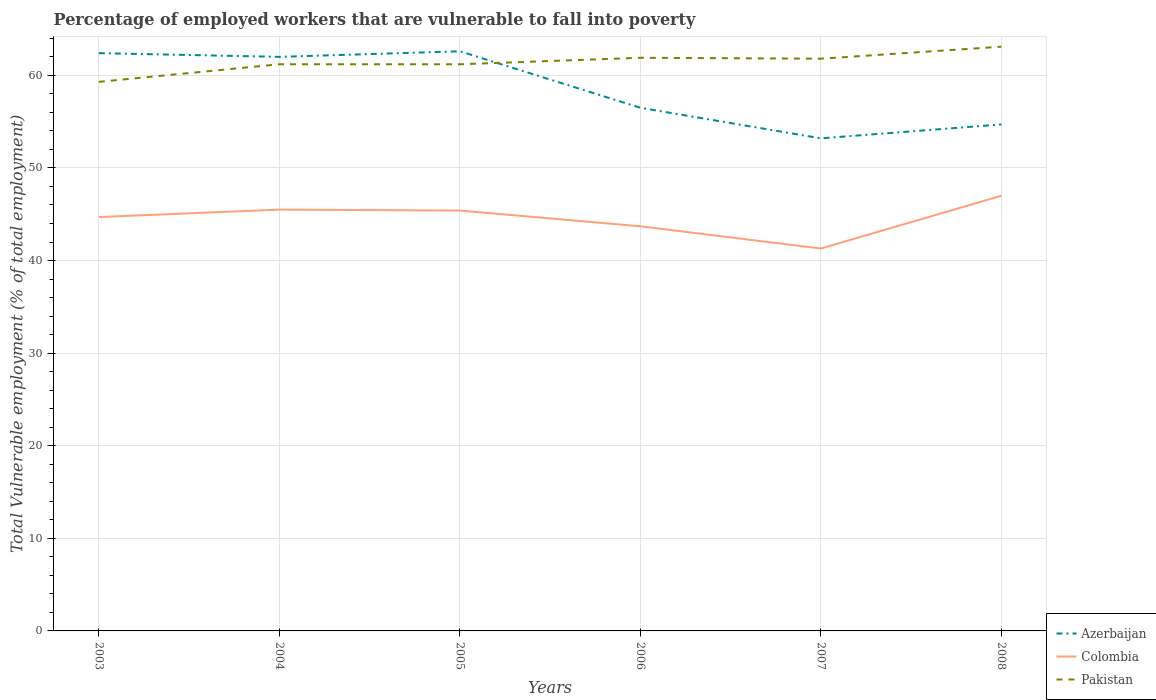Is the number of lines equal to the number of legend labels?
Your answer should be compact. Yes. Across all years, what is the maximum percentage of employed workers who are vulnerable to fall into poverty in Azerbaijan?
Ensure brevity in your answer.  53.2. What is the total percentage of employed workers who are vulnerable to fall into poverty in Pakistan in the graph?
Your response must be concise. -0.7. What is the difference between the highest and the second highest percentage of employed workers who are vulnerable to fall into poverty in Azerbaijan?
Offer a terse response. 9.4. How many lines are there?
Offer a very short reply. 3. How many years are there in the graph?
Your answer should be compact. 6. What is the difference between two consecutive major ticks on the Y-axis?
Give a very brief answer. 10. Are the values on the major ticks of Y-axis written in scientific E-notation?
Ensure brevity in your answer.  No. Does the graph contain grids?
Your response must be concise. Yes. How many legend labels are there?
Your response must be concise. 3. What is the title of the graph?
Offer a very short reply. Percentage of employed workers that are vulnerable to fall into poverty. What is the label or title of the Y-axis?
Offer a terse response. Total Vulnerable employment (% of total employment). What is the Total Vulnerable employment (% of total employment) of Azerbaijan in 2003?
Give a very brief answer. 62.4. What is the Total Vulnerable employment (% of total employment) in Colombia in 2003?
Your answer should be compact. 44.7. What is the Total Vulnerable employment (% of total employment) of Pakistan in 2003?
Your answer should be very brief. 59.3. What is the Total Vulnerable employment (% of total employment) of Azerbaijan in 2004?
Offer a terse response. 62. What is the Total Vulnerable employment (% of total employment) in Colombia in 2004?
Offer a very short reply. 45.5. What is the Total Vulnerable employment (% of total employment) of Pakistan in 2004?
Offer a terse response. 61.2. What is the Total Vulnerable employment (% of total employment) of Azerbaijan in 2005?
Your response must be concise. 62.6. What is the Total Vulnerable employment (% of total employment) in Colombia in 2005?
Offer a very short reply. 45.4. What is the Total Vulnerable employment (% of total employment) in Pakistan in 2005?
Keep it short and to the point. 61.2. What is the Total Vulnerable employment (% of total employment) in Azerbaijan in 2006?
Make the answer very short. 56.5. What is the Total Vulnerable employment (% of total employment) of Colombia in 2006?
Provide a succinct answer. 43.7. What is the Total Vulnerable employment (% of total employment) of Pakistan in 2006?
Your response must be concise. 61.9. What is the Total Vulnerable employment (% of total employment) in Azerbaijan in 2007?
Your answer should be very brief. 53.2. What is the Total Vulnerable employment (% of total employment) of Colombia in 2007?
Give a very brief answer. 41.3. What is the Total Vulnerable employment (% of total employment) in Pakistan in 2007?
Provide a short and direct response. 61.8. What is the Total Vulnerable employment (% of total employment) in Azerbaijan in 2008?
Offer a very short reply. 54.7. What is the Total Vulnerable employment (% of total employment) in Pakistan in 2008?
Provide a succinct answer. 63.1. Across all years, what is the maximum Total Vulnerable employment (% of total employment) in Azerbaijan?
Make the answer very short. 62.6. Across all years, what is the maximum Total Vulnerable employment (% of total employment) of Pakistan?
Your answer should be compact. 63.1. Across all years, what is the minimum Total Vulnerable employment (% of total employment) of Azerbaijan?
Make the answer very short. 53.2. Across all years, what is the minimum Total Vulnerable employment (% of total employment) of Colombia?
Provide a short and direct response. 41.3. Across all years, what is the minimum Total Vulnerable employment (% of total employment) in Pakistan?
Offer a terse response. 59.3. What is the total Total Vulnerable employment (% of total employment) in Azerbaijan in the graph?
Offer a terse response. 351.4. What is the total Total Vulnerable employment (% of total employment) of Colombia in the graph?
Your answer should be very brief. 267.6. What is the total Total Vulnerable employment (% of total employment) of Pakistan in the graph?
Offer a terse response. 368.5. What is the difference between the Total Vulnerable employment (% of total employment) of Azerbaijan in 2003 and that in 2004?
Your response must be concise. 0.4. What is the difference between the Total Vulnerable employment (% of total employment) of Colombia in 2003 and that in 2004?
Ensure brevity in your answer.  -0.8. What is the difference between the Total Vulnerable employment (% of total employment) of Azerbaijan in 2003 and that in 2005?
Your answer should be very brief. -0.2. What is the difference between the Total Vulnerable employment (% of total employment) in Colombia in 2003 and that in 2005?
Keep it short and to the point. -0.7. What is the difference between the Total Vulnerable employment (% of total employment) of Pakistan in 2003 and that in 2006?
Provide a short and direct response. -2.6. What is the difference between the Total Vulnerable employment (% of total employment) in Azerbaijan in 2003 and that in 2007?
Make the answer very short. 9.2. What is the difference between the Total Vulnerable employment (% of total employment) in Colombia in 2003 and that in 2007?
Keep it short and to the point. 3.4. What is the difference between the Total Vulnerable employment (% of total employment) of Pakistan in 2003 and that in 2007?
Your response must be concise. -2.5. What is the difference between the Total Vulnerable employment (% of total employment) in Colombia in 2003 and that in 2008?
Your answer should be compact. -2.3. What is the difference between the Total Vulnerable employment (% of total employment) in Pakistan in 2004 and that in 2005?
Offer a very short reply. 0. What is the difference between the Total Vulnerable employment (% of total employment) in Azerbaijan in 2004 and that in 2006?
Ensure brevity in your answer.  5.5. What is the difference between the Total Vulnerable employment (% of total employment) of Colombia in 2004 and that in 2006?
Provide a succinct answer. 1.8. What is the difference between the Total Vulnerable employment (% of total employment) of Azerbaijan in 2004 and that in 2007?
Provide a short and direct response. 8.8. What is the difference between the Total Vulnerable employment (% of total employment) of Colombia in 2004 and that in 2007?
Your answer should be compact. 4.2. What is the difference between the Total Vulnerable employment (% of total employment) in Azerbaijan in 2004 and that in 2008?
Offer a terse response. 7.3. What is the difference between the Total Vulnerable employment (% of total employment) in Colombia in 2004 and that in 2008?
Provide a short and direct response. -1.5. What is the difference between the Total Vulnerable employment (% of total employment) of Colombia in 2005 and that in 2006?
Provide a short and direct response. 1.7. What is the difference between the Total Vulnerable employment (% of total employment) of Pakistan in 2005 and that in 2006?
Your answer should be compact. -0.7. What is the difference between the Total Vulnerable employment (% of total employment) in Azerbaijan in 2005 and that in 2007?
Make the answer very short. 9.4. What is the difference between the Total Vulnerable employment (% of total employment) in Colombia in 2005 and that in 2007?
Offer a very short reply. 4.1. What is the difference between the Total Vulnerable employment (% of total employment) of Pakistan in 2005 and that in 2007?
Ensure brevity in your answer.  -0.6. What is the difference between the Total Vulnerable employment (% of total employment) of Azerbaijan in 2005 and that in 2008?
Provide a short and direct response. 7.9. What is the difference between the Total Vulnerable employment (% of total employment) in Colombia in 2005 and that in 2008?
Keep it short and to the point. -1.6. What is the difference between the Total Vulnerable employment (% of total employment) of Pakistan in 2005 and that in 2008?
Keep it short and to the point. -1.9. What is the difference between the Total Vulnerable employment (% of total employment) in Azerbaijan in 2006 and that in 2007?
Your answer should be very brief. 3.3. What is the difference between the Total Vulnerable employment (% of total employment) of Colombia in 2006 and that in 2007?
Provide a succinct answer. 2.4. What is the difference between the Total Vulnerable employment (% of total employment) in Azerbaijan in 2006 and that in 2008?
Your answer should be very brief. 1.8. What is the difference between the Total Vulnerable employment (% of total employment) of Azerbaijan in 2007 and that in 2008?
Ensure brevity in your answer.  -1.5. What is the difference between the Total Vulnerable employment (% of total employment) of Colombia in 2003 and the Total Vulnerable employment (% of total employment) of Pakistan in 2004?
Ensure brevity in your answer.  -16.5. What is the difference between the Total Vulnerable employment (% of total employment) of Azerbaijan in 2003 and the Total Vulnerable employment (% of total employment) of Pakistan in 2005?
Provide a succinct answer. 1.2. What is the difference between the Total Vulnerable employment (% of total employment) in Colombia in 2003 and the Total Vulnerable employment (% of total employment) in Pakistan in 2005?
Offer a terse response. -16.5. What is the difference between the Total Vulnerable employment (% of total employment) of Azerbaijan in 2003 and the Total Vulnerable employment (% of total employment) of Pakistan in 2006?
Your response must be concise. 0.5. What is the difference between the Total Vulnerable employment (% of total employment) of Colombia in 2003 and the Total Vulnerable employment (% of total employment) of Pakistan in 2006?
Give a very brief answer. -17.2. What is the difference between the Total Vulnerable employment (% of total employment) of Azerbaijan in 2003 and the Total Vulnerable employment (% of total employment) of Colombia in 2007?
Provide a short and direct response. 21.1. What is the difference between the Total Vulnerable employment (% of total employment) in Azerbaijan in 2003 and the Total Vulnerable employment (% of total employment) in Pakistan in 2007?
Make the answer very short. 0.6. What is the difference between the Total Vulnerable employment (% of total employment) in Colombia in 2003 and the Total Vulnerable employment (% of total employment) in Pakistan in 2007?
Offer a terse response. -17.1. What is the difference between the Total Vulnerable employment (% of total employment) in Colombia in 2003 and the Total Vulnerable employment (% of total employment) in Pakistan in 2008?
Your answer should be very brief. -18.4. What is the difference between the Total Vulnerable employment (% of total employment) in Azerbaijan in 2004 and the Total Vulnerable employment (% of total employment) in Colombia in 2005?
Give a very brief answer. 16.6. What is the difference between the Total Vulnerable employment (% of total employment) in Azerbaijan in 2004 and the Total Vulnerable employment (% of total employment) in Pakistan in 2005?
Give a very brief answer. 0.8. What is the difference between the Total Vulnerable employment (% of total employment) in Colombia in 2004 and the Total Vulnerable employment (% of total employment) in Pakistan in 2005?
Offer a very short reply. -15.7. What is the difference between the Total Vulnerable employment (% of total employment) in Azerbaijan in 2004 and the Total Vulnerable employment (% of total employment) in Pakistan in 2006?
Ensure brevity in your answer.  0.1. What is the difference between the Total Vulnerable employment (% of total employment) of Colombia in 2004 and the Total Vulnerable employment (% of total employment) of Pakistan in 2006?
Your answer should be very brief. -16.4. What is the difference between the Total Vulnerable employment (% of total employment) of Azerbaijan in 2004 and the Total Vulnerable employment (% of total employment) of Colombia in 2007?
Your response must be concise. 20.7. What is the difference between the Total Vulnerable employment (% of total employment) of Azerbaijan in 2004 and the Total Vulnerable employment (% of total employment) of Pakistan in 2007?
Offer a terse response. 0.2. What is the difference between the Total Vulnerable employment (% of total employment) in Colombia in 2004 and the Total Vulnerable employment (% of total employment) in Pakistan in 2007?
Your answer should be very brief. -16.3. What is the difference between the Total Vulnerable employment (% of total employment) in Azerbaijan in 2004 and the Total Vulnerable employment (% of total employment) in Colombia in 2008?
Your answer should be very brief. 15. What is the difference between the Total Vulnerable employment (% of total employment) of Colombia in 2004 and the Total Vulnerable employment (% of total employment) of Pakistan in 2008?
Give a very brief answer. -17.6. What is the difference between the Total Vulnerable employment (% of total employment) in Azerbaijan in 2005 and the Total Vulnerable employment (% of total employment) in Colombia in 2006?
Make the answer very short. 18.9. What is the difference between the Total Vulnerable employment (% of total employment) of Colombia in 2005 and the Total Vulnerable employment (% of total employment) of Pakistan in 2006?
Your answer should be compact. -16.5. What is the difference between the Total Vulnerable employment (% of total employment) of Azerbaijan in 2005 and the Total Vulnerable employment (% of total employment) of Colombia in 2007?
Your answer should be very brief. 21.3. What is the difference between the Total Vulnerable employment (% of total employment) in Colombia in 2005 and the Total Vulnerable employment (% of total employment) in Pakistan in 2007?
Your response must be concise. -16.4. What is the difference between the Total Vulnerable employment (% of total employment) in Colombia in 2005 and the Total Vulnerable employment (% of total employment) in Pakistan in 2008?
Provide a succinct answer. -17.7. What is the difference between the Total Vulnerable employment (% of total employment) in Azerbaijan in 2006 and the Total Vulnerable employment (% of total employment) in Pakistan in 2007?
Your answer should be compact. -5.3. What is the difference between the Total Vulnerable employment (% of total employment) of Colombia in 2006 and the Total Vulnerable employment (% of total employment) of Pakistan in 2007?
Provide a succinct answer. -18.1. What is the difference between the Total Vulnerable employment (% of total employment) in Azerbaijan in 2006 and the Total Vulnerable employment (% of total employment) in Colombia in 2008?
Keep it short and to the point. 9.5. What is the difference between the Total Vulnerable employment (% of total employment) of Colombia in 2006 and the Total Vulnerable employment (% of total employment) of Pakistan in 2008?
Give a very brief answer. -19.4. What is the difference between the Total Vulnerable employment (% of total employment) in Colombia in 2007 and the Total Vulnerable employment (% of total employment) in Pakistan in 2008?
Make the answer very short. -21.8. What is the average Total Vulnerable employment (% of total employment) in Azerbaijan per year?
Ensure brevity in your answer.  58.57. What is the average Total Vulnerable employment (% of total employment) in Colombia per year?
Offer a terse response. 44.6. What is the average Total Vulnerable employment (% of total employment) of Pakistan per year?
Your response must be concise. 61.42. In the year 2003, what is the difference between the Total Vulnerable employment (% of total employment) in Azerbaijan and Total Vulnerable employment (% of total employment) in Pakistan?
Make the answer very short. 3.1. In the year 2003, what is the difference between the Total Vulnerable employment (% of total employment) of Colombia and Total Vulnerable employment (% of total employment) of Pakistan?
Ensure brevity in your answer.  -14.6. In the year 2004, what is the difference between the Total Vulnerable employment (% of total employment) in Azerbaijan and Total Vulnerable employment (% of total employment) in Colombia?
Your answer should be very brief. 16.5. In the year 2004, what is the difference between the Total Vulnerable employment (% of total employment) of Colombia and Total Vulnerable employment (% of total employment) of Pakistan?
Keep it short and to the point. -15.7. In the year 2005, what is the difference between the Total Vulnerable employment (% of total employment) of Azerbaijan and Total Vulnerable employment (% of total employment) of Pakistan?
Make the answer very short. 1.4. In the year 2005, what is the difference between the Total Vulnerable employment (% of total employment) in Colombia and Total Vulnerable employment (% of total employment) in Pakistan?
Provide a succinct answer. -15.8. In the year 2006, what is the difference between the Total Vulnerable employment (% of total employment) in Azerbaijan and Total Vulnerable employment (% of total employment) in Pakistan?
Keep it short and to the point. -5.4. In the year 2006, what is the difference between the Total Vulnerable employment (% of total employment) in Colombia and Total Vulnerable employment (% of total employment) in Pakistan?
Make the answer very short. -18.2. In the year 2007, what is the difference between the Total Vulnerable employment (% of total employment) in Colombia and Total Vulnerable employment (% of total employment) in Pakistan?
Offer a terse response. -20.5. In the year 2008, what is the difference between the Total Vulnerable employment (% of total employment) of Azerbaijan and Total Vulnerable employment (% of total employment) of Colombia?
Provide a succinct answer. 7.7. In the year 2008, what is the difference between the Total Vulnerable employment (% of total employment) in Colombia and Total Vulnerable employment (% of total employment) in Pakistan?
Your answer should be compact. -16.1. What is the ratio of the Total Vulnerable employment (% of total employment) of Colombia in 2003 to that in 2004?
Provide a succinct answer. 0.98. What is the ratio of the Total Vulnerable employment (% of total employment) of Azerbaijan in 2003 to that in 2005?
Give a very brief answer. 1. What is the ratio of the Total Vulnerable employment (% of total employment) in Colombia in 2003 to that in 2005?
Ensure brevity in your answer.  0.98. What is the ratio of the Total Vulnerable employment (% of total employment) in Pakistan in 2003 to that in 2005?
Give a very brief answer. 0.97. What is the ratio of the Total Vulnerable employment (% of total employment) in Azerbaijan in 2003 to that in 2006?
Your answer should be very brief. 1.1. What is the ratio of the Total Vulnerable employment (% of total employment) in Colombia in 2003 to that in 2006?
Your answer should be compact. 1.02. What is the ratio of the Total Vulnerable employment (% of total employment) in Pakistan in 2003 to that in 2006?
Your answer should be very brief. 0.96. What is the ratio of the Total Vulnerable employment (% of total employment) in Azerbaijan in 2003 to that in 2007?
Keep it short and to the point. 1.17. What is the ratio of the Total Vulnerable employment (% of total employment) of Colombia in 2003 to that in 2007?
Make the answer very short. 1.08. What is the ratio of the Total Vulnerable employment (% of total employment) of Pakistan in 2003 to that in 2007?
Provide a short and direct response. 0.96. What is the ratio of the Total Vulnerable employment (% of total employment) of Azerbaijan in 2003 to that in 2008?
Ensure brevity in your answer.  1.14. What is the ratio of the Total Vulnerable employment (% of total employment) of Colombia in 2003 to that in 2008?
Give a very brief answer. 0.95. What is the ratio of the Total Vulnerable employment (% of total employment) of Pakistan in 2003 to that in 2008?
Provide a succinct answer. 0.94. What is the ratio of the Total Vulnerable employment (% of total employment) of Azerbaijan in 2004 to that in 2005?
Offer a very short reply. 0.99. What is the ratio of the Total Vulnerable employment (% of total employment) of Colombia in 2004 to that in 2005?
Offer a terse response. 1. What is the ratio of the Total Vulnerable employment (% of total employment) of Azerbaijan in 2004 to that in 2006?
Ensure brevity in your answer.  1.1. What is the ratio of the Total Vulnerable employment (% of total employment) of Colombia in 2004 to that in 2006?
Provide a succinct answer. 1.04. What is the ratio of the Total Vulnerable employment (% of total employment) in Pakistan in 2004 to that in 2006?
Your answer should be very brief. 0.99. What is the ratio of the Total Vulnerable employment (% of total employment) of Azerbaijan in 2004 to that in 2007?
Give a very brief answer. 1.17. What is the ratio of the Total Vulnerable employment (% of total employment) of Colombia in 2004 to that in 2007?
Your response must be concise. 1.1. What is the ratio of the Total Vulnerable employment (% of total employment) of Pakistan in 2004 to that in 2007?
Offer a terse response. 0.99. What is the ratio of the Total Vulnerable employment (% of total employment) of Azerbaijan in 2004 to that in 2008?
Keep it short and to the point. 1.13. What is the ratio of the Total Vulnerable employment (% of total employment) in Colombia in 2004 to that in 2008?
Ensure brevity in your answer.  0.97. What is the ratio of the Total Vulnerable employment (% of total employment) in Pakistan in 2004 to that in 2008?
Make the answer very short. 0.97. What is the ratio of the Total Vulnerable employment (% of total employment) in Azerbaijan in 2005 to that in 2006?
Ensure brevity in your answer.  1.11. What is the ratio of the Total Vulnerable employment (% of total employment) of Colombia in 2005 to that in 2006?
Your answer should be compact. 1.04. What is the ratio of the Total Vulnerable employment (% of total employment) in Pakistan in 2005 to that in 2006?
Make the answer very short. 0.99. What is the ratio of the Total Vulnerable employment (% of total employment) of Azerbaijan in 2005 to that in 2007?
Keep it short and to the point. 1.18. What is the ratio of the Total Vulnerable employment (% of total employment) of Colombia in 2005 to that in 2007?
Your answer should be compact. 1.1. What is the ratio of the Total Vulnerable employment (% of total employment) of Pakistan in 2005 to that in 2007?
Provide a short and direct response. 0.99. What is the ratio of the Total Vulnerable employment (% of total employment) in Azerbaijan in 2005 to that in 2008?
Ensure brevity in your answer.  1.14. What is the ratio of the Total Vulnerable employment (% of total employment) of Colombia in 2005 to that in 2008?
Give a very brief answer. 0.97. What is the ratio of the Total Vulnerable employment (% of total employment) of Pakistan in 2005 to that in 2008?
Provide a succinct answer. 0.97. What is the ratio of the Total Vulnerable employment (% of total employment) in Azerbaijan in 2006 to that in 2007?
Ensure brevity in your answer.  1.06. What is the ratio of the Total Vulnerable employment (% of total employment) in Colombia in 2006 to that in 2007?
Your answer should be compact. 1.06. What is the ratio of the Total Vulnerable employment (% of total employment) in Azerbaijan in 2006 to that in 2008?
Keep it short and to the point. 1.03. What is the ratio of the Total Vulnerable employment (% of total employment) of Colombia in 2006 to that in 2008?
Make the answer very short. 0.93. What is the ratio of the Total Vulnerable employment (% of total employment) in Azerbaijan in 2007 to that in 2008?
Your answer should be compact. 0.97. What is the ratio of the Total Vulnerable employment (% of total employment) of Colombia in 2007 to that in 2008?
Your answer should be very brief. 0.88. What is the ratio of the Total Vulnerable employment (% of total employment) of Pakistan in 2007 to that in 2008?
Provide a short and direct response. 0.98. What is the difference between the highest and the lowest Total Vulnerable employment (% of total employment) of Azerbaijan?
Your answer should be very brief. 9.4. What is the difference between the highest and the lowest Total Vulnerable employment (% of total employment) of Colombia?
Provide a succinct answer. 5.7. 